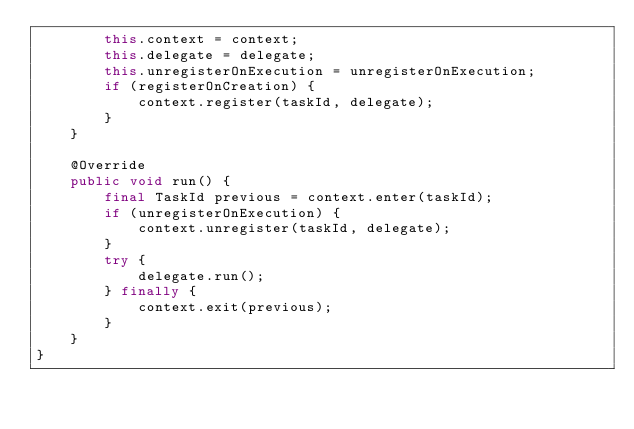<code> <loc_0><loc_0><loc_500><loc_500><_Java_>        this.context = context;
        this.delegate = delegate;
        this.unregisterOnExecution = unregisterOnExecution;
        if (registerOnCreation) {
            context.register(taskId, delegate);
        }
    }

    @Override
    public void run() {
        final TaskId previous = context.enter(taskId);
        if (unregisterOnExecution) {
            context.unregister(taskId, delegate);
        }
        try {
            delegate.run();
        } finally {
            context.exit(previous);
        }
    }
}
</code> 